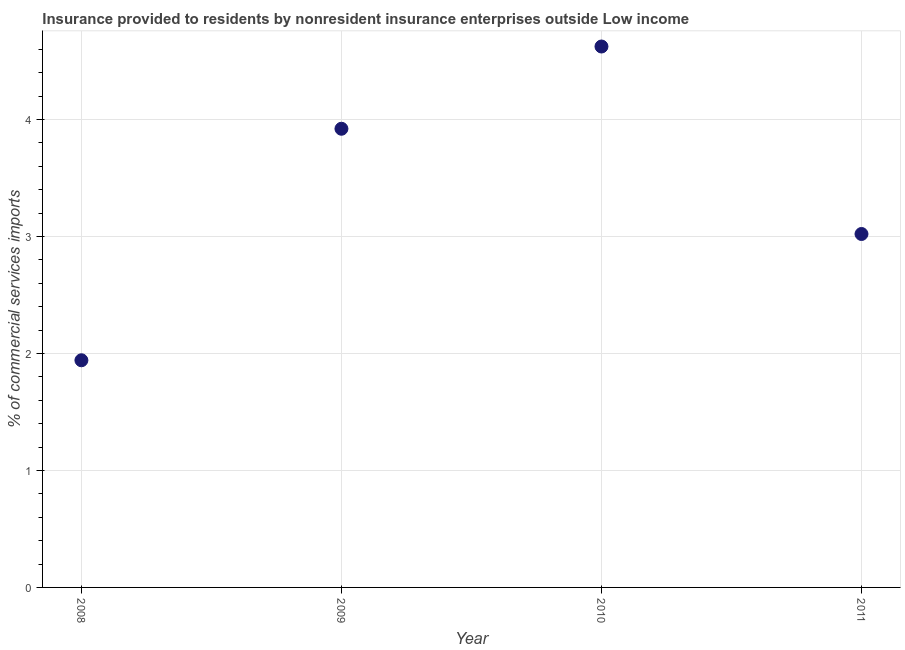What is the insurance provided by non-residents in 2011?
Make the answer very short. 3.02. Across all years, what is the maximum insurance provided by non-residents?
Your response must be concise. 4.62. Across all years, what is the minimum insurance provided by non-residents?
Your response must be concise. 1.94. In which year was the insurance provided by non-residents maximum?
Offer a very short reply. 2010. In which year was the insurance provided by non-residents minimum?
Provide a short and direct response. 2008. What is the sum of the insurance provided by non-residents?
Your response must be concise. 13.51. What is the difference between the insurance provided by non-residents in 2009 and 2010?
Your answer should be compact. -0.7. What is the average insurance provided by non-residents per year?
Your answer should be very brief. 3.38. What is the median insurance provided by non-residents?
Offer a terse response. 3.47. What is the ratio of the insurance provided by non-residents in 2008 to that in 2010?
Keep it short and to the point. 0.42. What is the difference between the highest and the second highest insurance provided by non-residents?
Ensure brevity in your answer.  0.7. Is the sum of the insurance provided by non-residents in 2010 and 2011 greater than the maximum insurance provided by non-residents across all years?
Your answer should be compact. Yes. What is the difference between the highest and the lowest insurance provided by non-residents?
Your answer should be very brief. 2.68. Does the insurance provided by non-residents monotonically increase over the years?
Offer a very short reply. No. How many dotlines are there?
Ensure brevity in your answer.  1. What is the difference between two consecutive major ticks on the Y-axis?
Give a very brief answer. 1. Does the graph contain any zero values?
Provide a short and direct response. No. What is the title of the graph?
Your response must be concise. Insurance provided to residents by nonresident insurance enterprises outside Low income. What is the label or title of the Y-axis?
Make the answer very short. % of commercial services imports. What is the % of commercial services imports in 2008?
Keep it short and to the point. 1.94. What is the % of commercial services imports in 2009?
Make the answer very short. 3.92. What is the % of commercial services imports in 2010?
Offer a terse response. 4.62. What is the % of commercial services imports in 2011?
Keep it short and to the point. 3.02. What is the difference between the % of commercial services imports in 2008 and 2009?
Your response must be concise. -1.98. What is the difference between the % of commercial services imports in 2008 and 2010?
Give a very brief answer. -2.68. What is the difference between the % of commercial services imports in 2008 and 2011?
Your response must be concise. -1.08. What is the difference between the % of commercial services imports in 2009 and 2010?
Your answer should be compact. -0.7. What is the difference between the % of commercial services imports in 2009 and 2011?
Give a very brief answer. 0.9. What is the difference between the % of commercial services imports in 2010 and 2011?
Your response must be concise. 1.6. What is the ratio of the % of commercial services imports in 2008 to that in 2009?
Offer a terse response. 0.49. What is the ratio of the % of commercial services imports in 2008 to that in 2010?
Provide a succinct answer. 0.42. What is the ratio of the % of commercial services imports in 2008 to that in 2011?
Your answer should be compact. 0.64. What is the ratio of the % of commercial services imports in 2009 to that in 2010?
Make the answer very short. 0.85. What is the ratio of the % of commercial services imports in 2009 to that in 2011?
Offer a terse response. 1.3. What is the ratio of the % of commercial services imports in 2010 to that in 2011?
Give a very brief answer. 1.53. 